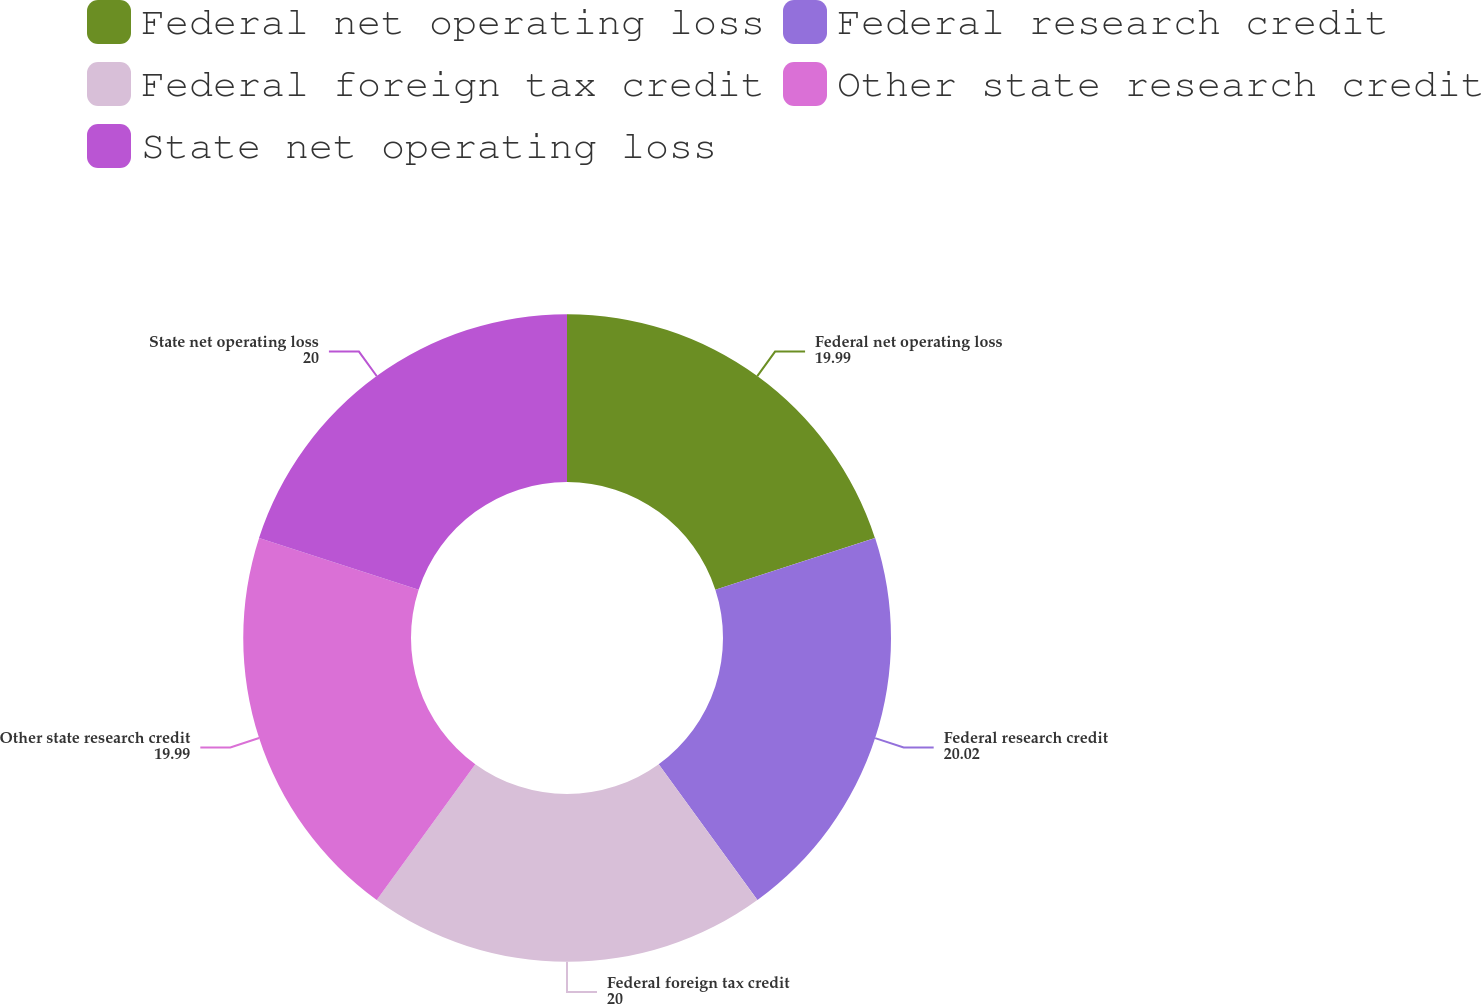<chart> <loc_0><loc_0><loc_500><loc_500><pie_chart><fcel>Federal net operating loss<fcel>Federal research credit<fcel>Federal foreign tax credit<fcel>Other state research credit<fcel>State net operating loss<nl><fcel>19.99%<fcel>20.02%<fcel>20.0%<fcel>19.99%<fcel>20.0%<nl></chart> 